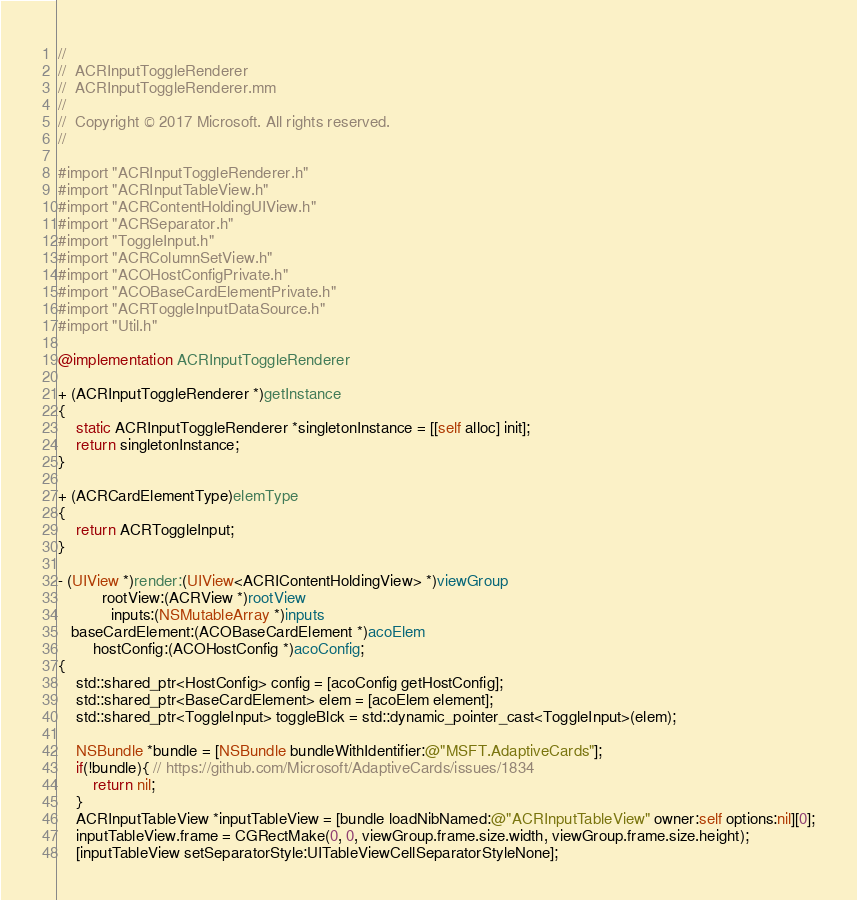<code> <loc_0><loc_0><loc_500><loc_500><_ObjectiveC_>//
//  ACRInputToggleRenderer
//  ACRInputToggleRenderer.mm
//
//  Copyright © 2017 Microsoft. All rights reserved.
//

#import "ACRInputToggleRenderer.h"
#import "ACRInputTableView.h"
#import "ACRContentHoldingUIView.h"
#import "ACRSeparator.h"
#import "ToggleInput.h"
#import "ACRColumnSetView.h"
#import "ACOHostConfigPrivate.h"
#import "ACOBaseCardElementPrivate.h"
#import "ACRToggleInputDataSource.h"
#import "Util.h"

@implementation ACRInputToggleRenderer

+ (ACRInputToggleRenderer *)getInstance
{
    static ACRInputToggleRenderer *singletonInstance = [[self alloc] init];
    return singletonInstance;
}

+ (ACRCardElementType)elemType
{
    return ACRToggleInput;
}

- (UIView *)render:(UIView<ACRIContentHoldingView> *)viewGroup
          rootView:(ACRView *)rootView
            inputs:(NSMutableArray *)inputs
   baseCardElement:(ACOBaseCardElement *)acoElem
        hostConfig:(ACOHostConfig *)acoConfig;
{
    std::shared_ptr<HostConfig> config = [acoConfig getHostConfig];
    std::shared_ptr<BaseCardElement> elem = [acoElem element];
    std::shared_ptr<ToggleInput> toggleBlck = std::dynamic_pointer_cast<ToggleInput>(elem);

    NSBundle *bundle = [NSBundle bundleWithIdentifier:@"MSFT.AdaptiveCards"];
    if(!bundle){ // https://github.com/Microsoft/AdaptiveCards/issues/1834
        return nil;
    }
    ACRInputTableView *inputTableView = [bundle loadNibNamed:@"ACRInputTableView" owner:self options:nil][0];
    inputTableView.frame = CGRectMake(0, 0, viewGroup.frame.size.width, viewGroup.frame.size.height);
    [inputTableView setSeparatorStyle:UITableViewCellSeparatorStyleNone];</code> 